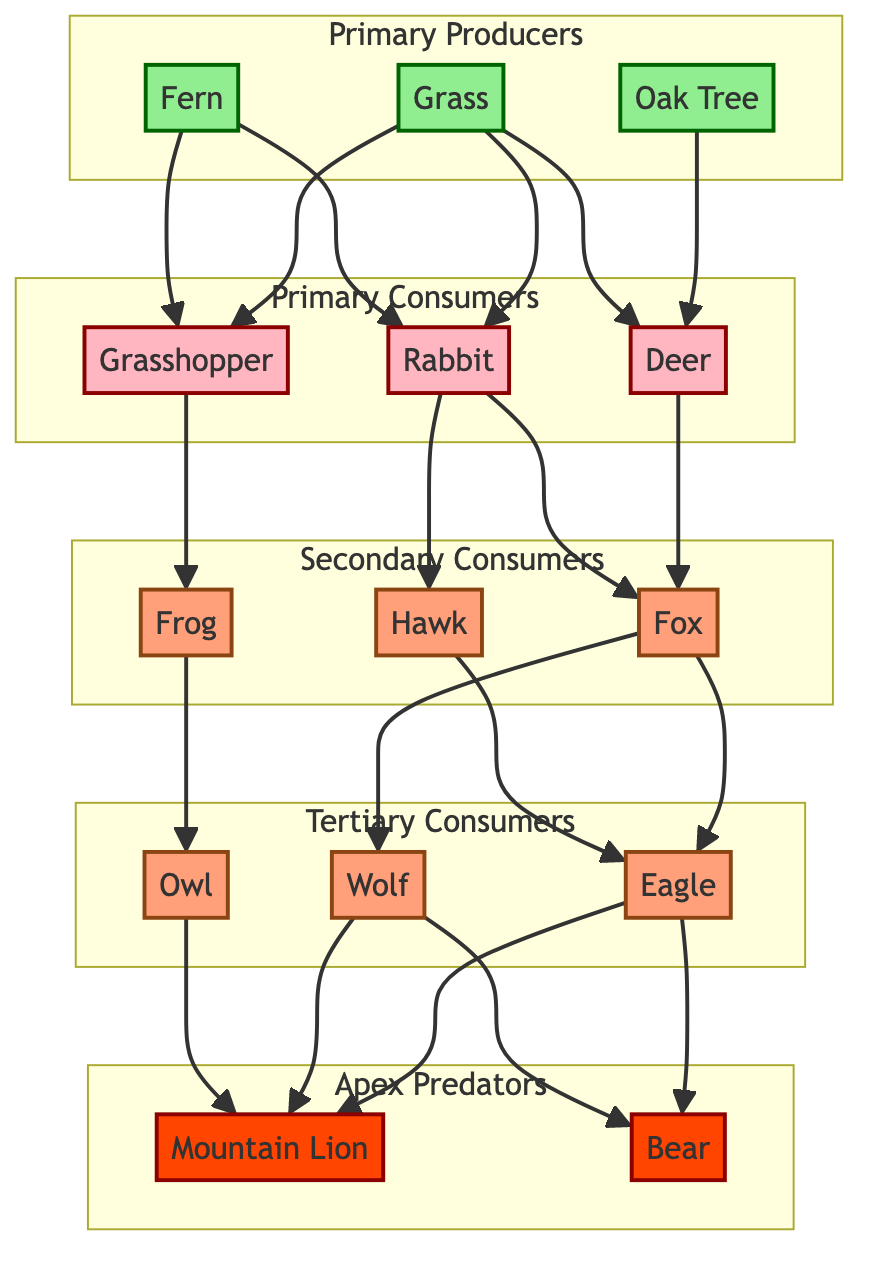What are the primary producers in the forest ecosystem? The diagram lists three primary producers: Oak Tree, Grass, and Fern. These are foundational elements in the food chain that produce energy through photosynthesis.
Answer: Oak Tree, Grass, Fern How many primary consumers are in the diagram? The diagram shows three primary consumers: Deer, Rabbit, and Grasshopper. Counting these provides the answer.
Answer: 3 Which consumer is eaten by both the Fox and the Hawk? By tracing the arrows, we can see that both the Fox and the Hawk consume the Rabbit, making it the common prey.
Answer: Rabbit What type of consumer is the Eagle classified as? The Eagle is positioned under the Tertiary Consumers section, indicating it is a tertiary consumer in this ecosystem.
Answer: Tertiary Consumer What apex predators are present in the diagram? The diagram identifies two apex predators: Mountain Lion and Bear, which sit at the top of the food chain.
Answer: Mountain Lion, Bear How many species are involved in the flow from grass to deer? The grass connects to the Deer directly. Since only Grass leads to Deer, we have two species interacting.
Answer: 2 Which predator is not a consumer of the Grasshopper? Reviewing the diagram shows that the Grasshopper is only consumed by the Frog and does not lead to any of the tertiary consumers apart from them. Thus, the Owl is not a consumer of the Grasshopper.
Answer: Owl What flows from the Deer to the Wolf? The diagram indicates that the Deer is a food source for the Fox, and then the Fox, in turn, is consumed by the Wolf, illustrating the flow.
Answer: Fox Which producers directly feed the Rabbit? The diagram shows that the Grass and Fern are the two producers that provide food directly to the Rabbit.
Answer: Grass, Fern 